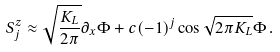Convert formula to latex. <formula><loc_0><loc_0><loc_500><loc_500>S ^ { z } _ { j } \approx \sqrt { \frac { K _ { L } } { 2 \pi } } \partial _ { x } \Phi + c ( - 1 ) ^ { j } \cos \sqrt { 2 \pi K _ { L } } \Phi \, .</formula> 